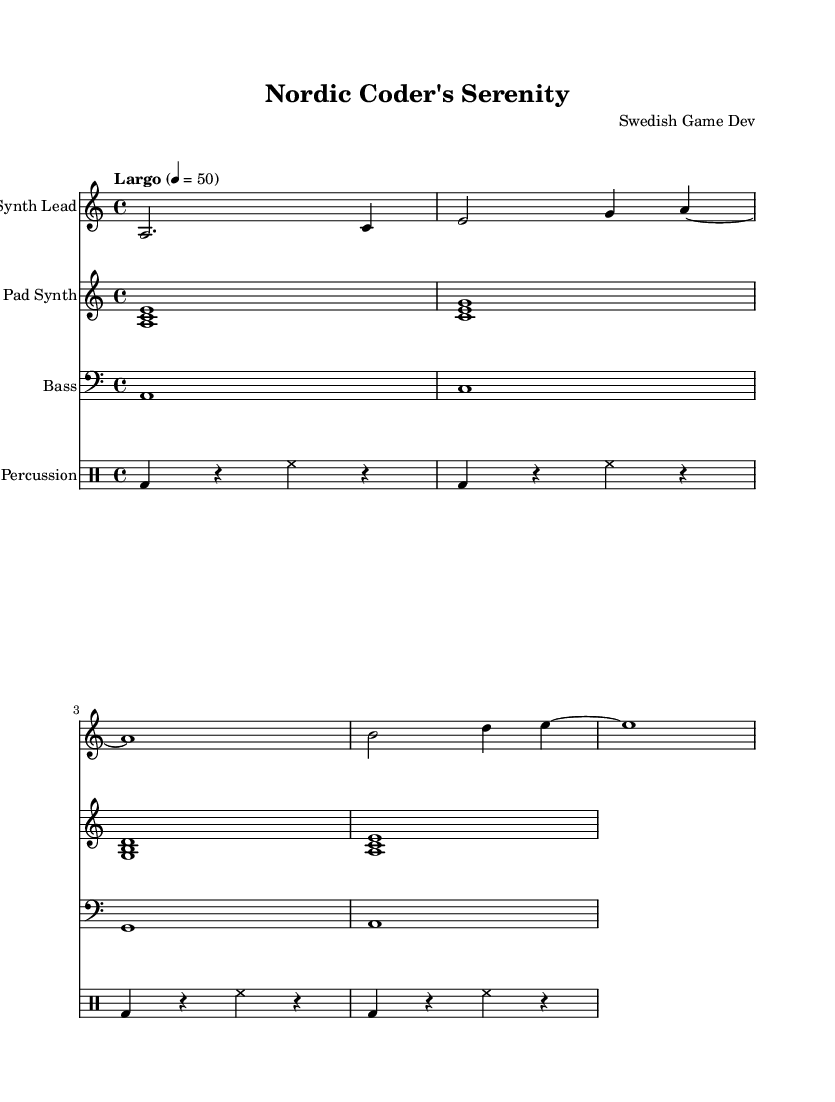What is the key signature of this music? The key signature is indicated by the presence of no sharps or flats, which corresponds to A minor. This can be seen in the global settings at the top of the score.
Answer: A minor What is the time signature of this music? The time signature is shown as three digits in the global settings section; here, it reads 4/4, meaning there are four beats per measure.
Answer: 4/4 What is the tempo marking in this piece? The tempo marking is explicitly stated in the global settings as "Largo" with a tempo marking of 50 beats per minute, indicating a slow pace for the piece.
Answer: Largo 50 How many measures are in the synth lead part? A careful count of the measures within the 'synthLead' voice indicates that it contains a total of four measures, each separated by a vertical line.
Answer: 4 What kind of synthesizer is used for the lead? The lead part is labeled "Synth Lead" in the score, which provides a clear indication of the type of instrument that should be played in that staff.
Answer: Synth Lead What type of percussion is featured in this piece? The percussion section is notated in the 'percussion' staff, where it uses standard drum notation with specific abbreviations for bass drum (bd) and hi-hat (hh).
Answer: Drum What is the general mood this music is intended to evoke? The overall mood can be inferred from the title "Nordic Coder's Serenity," suggesting a tranquil and atmospheric quality that is often associated with ambient music inspired by nature.
Answer: Serenity 